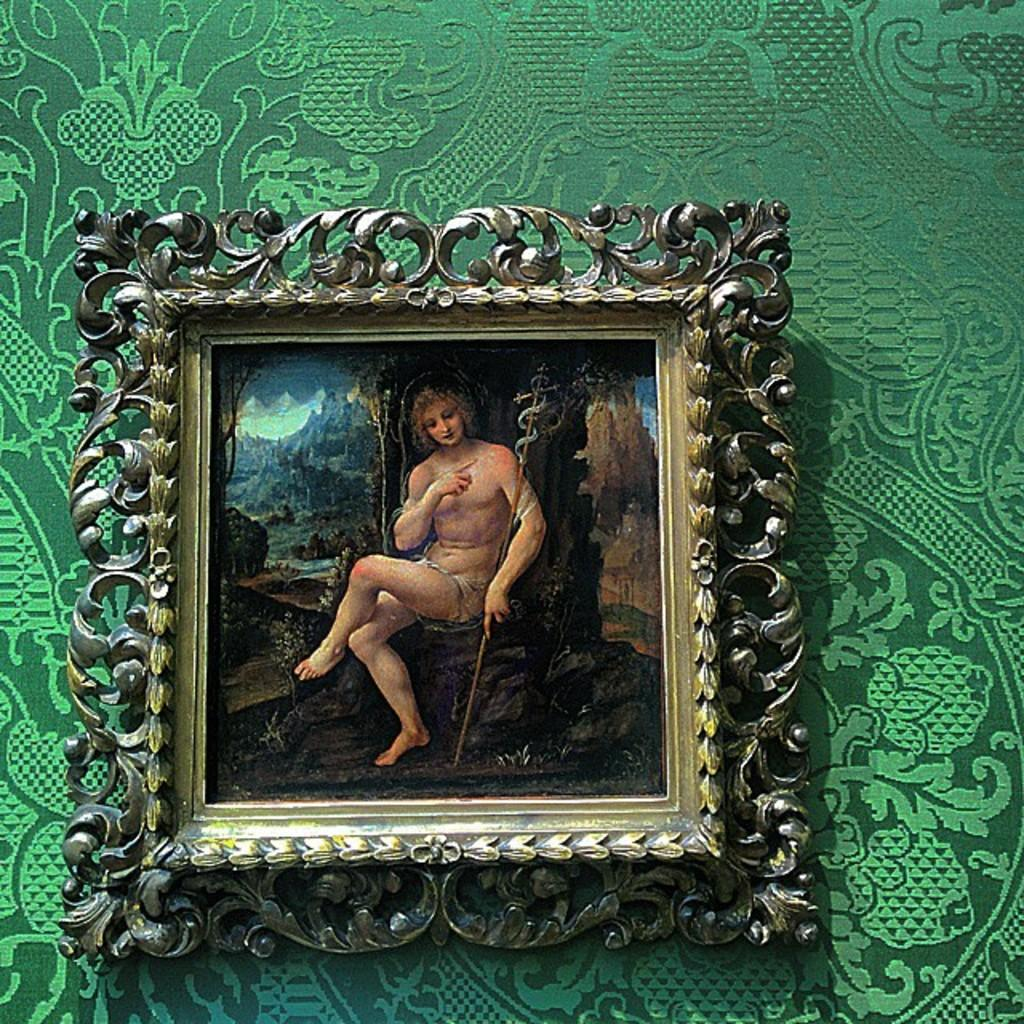What object is visible in the image that might hold a photo? There is a photo frame in the image. Where is the photo frame located? The photo frame is on a wall. What type of attention does the cabbage in the image receive? There is no cabbage present in the image, so it cannot receive any attention. 